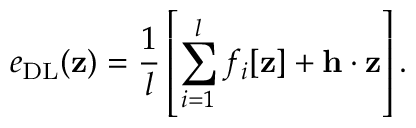Convert formula to latex. <formula><loc_0><loc_0><loc_500><loc_500>e _ { D L } ( z ) = \frac { 1 } { l } \left [ \sum _ { i = 1 } ^ { l } f _ { i } [ z ] + h \cdot z \right ] .</formula> 